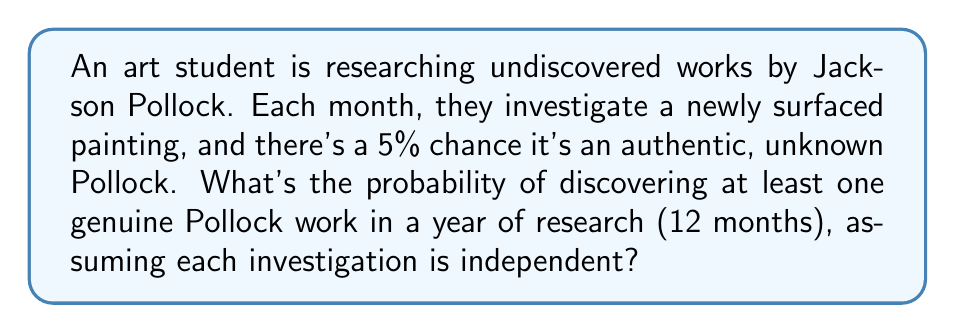Teach me how to tackle this problem. Let's approach this step-by-step using Bernoulli trials:

1) Each month's investigation is a Bernoulli trial with probability of success $p = 0.05$ (5% chance of finding a genuine Pollock).

2) We want to find the probability of at least one success in 12 trials (one year of research).

3) It's easier to calculate the probability of no successes and then subtract from 1:

   $P(\text{at least one success}) = 1 - P(\text{no successes})$

4) The probability of no successes in 12 independent trials is:

   $P(\text{no successes}) = (1-p)^{12} = (0.95)^{12}$

5) Now we can calculate:

   $P(\text{at least one success}) = 1 - (0.95)^{12}$

6) Using a calculator:

   $1 - (0.95)^{12} \approx 1 - 0.5404 = 0.4596$

7) Convert to a percentage:

   $0.4596 \times 100\% \approx 45.96\%$

Thus, there's approximately a 45.96% chance of discovering at least one genuine Pollock work in a year of research.
Answer: $45.96\%$ 